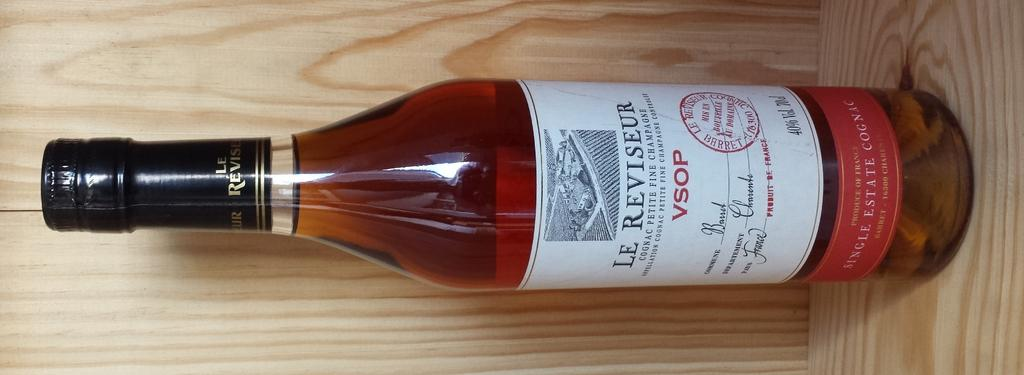<image>
Create a compact narrative representing the image presented. A bottle of Le Reviseur rose wine sits in a wooden display case 